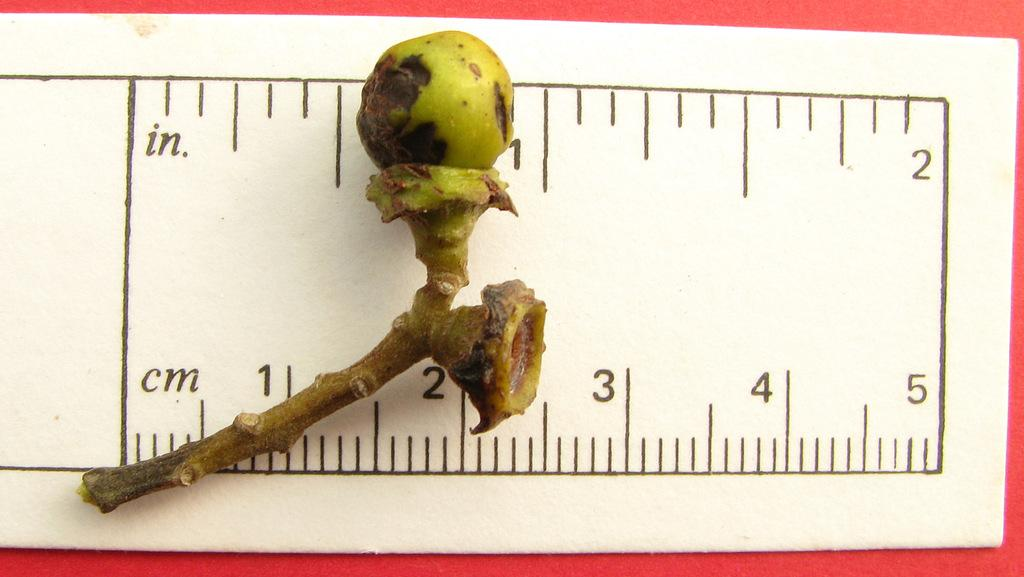<image>
Offer a succinct explanation of the picture presented. A piece of bone measures slightly less than an inch. 